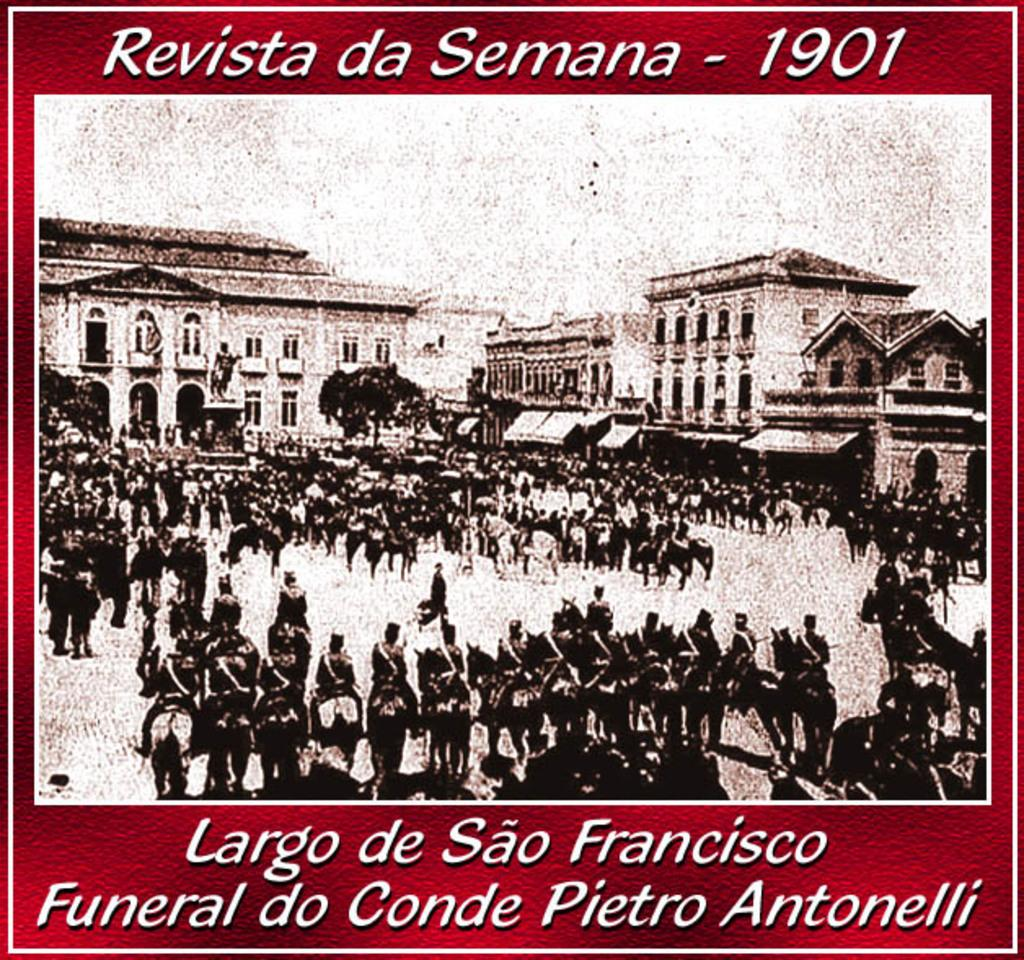<image>
Relay a brief, clear account of the picture shown. A 1901 photo of people in a town square 